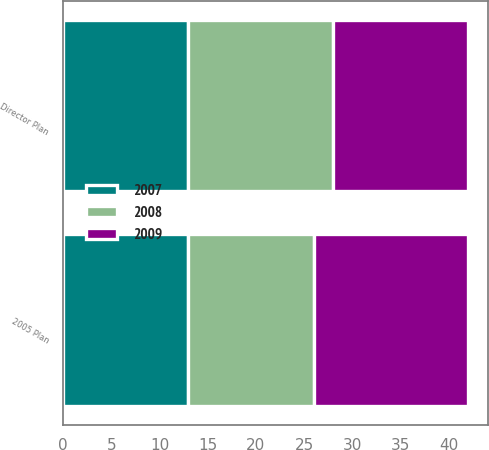Convert chart. <chart><loc_0><loc_0><loc_500><loc_500><stacked_bar_chart><ecel><fcel>2005 Plan<fcel>Director Plan<nl><fcel>2007<fcel>13<fcel>13<nl><fcel>2008<fcel>13<fcel>15<nl><fcel>2009<fcel>16<fcel>14<nl></chart> 